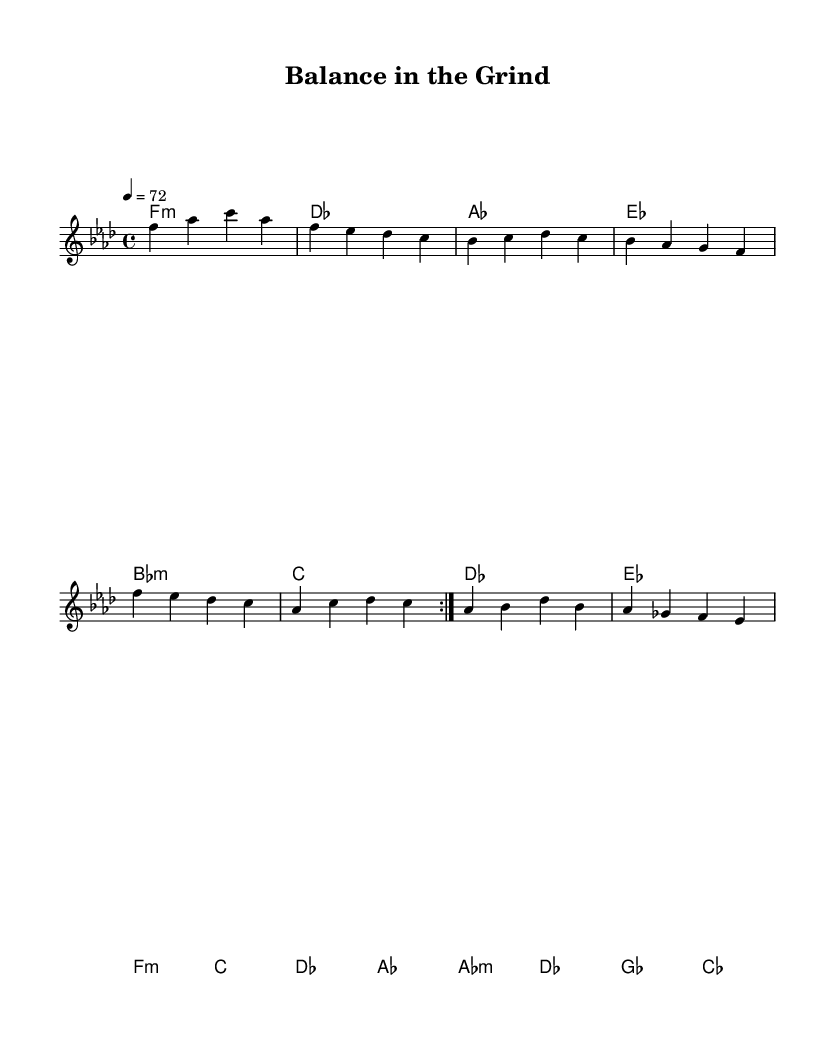What is the key signature of this music? The key signature indicates the key of F minor, which has four flats. This is determined by looking at the beginning of the sheet music where the flats are indicated.
Answer: F minor What is the time signature of this music? The time signature is 4/4, which means there are four beats in a measure and the quarter note gets one beat. This is visibly notated at the start of the sheet music.
Answer: 4/4 What is the tempo marking of this piece? The tempo marking is indicated as '4 = 72,' meaning there are 72 beats per minute, with each beat corresponding to a quarter note. This is explicitly noted in the header section of the sheet music.
Answer: 72 How many sections are there in the music? The music consists of three main sections: Verse, Pre-Chorus, and Chorus. The structure can be identified through the repeating patterns and distinct blocks of the sheet music.
Answer: Three What type of chords predominantly feature in this music? The music features minor chords predominantly, as shown by the chord labels, which indicate that the most frequently used chords are minor.
Answer: Minor What instrument is primarily featured in this score? The sheet music includes a staff notated for the treble clef, indicating that it is primarily written for instruments like the piano or voice that use the treble clef commonly.
Answer: Treble clef What is the overall theme reflected in this ballad? The theme predominantly reflects the struggle of work-life balance and career ambitions as implied by the title 'Balance in the Grind' and the emotional content suggested by the chord progressions and melodies.
Answer: Work-life balance 